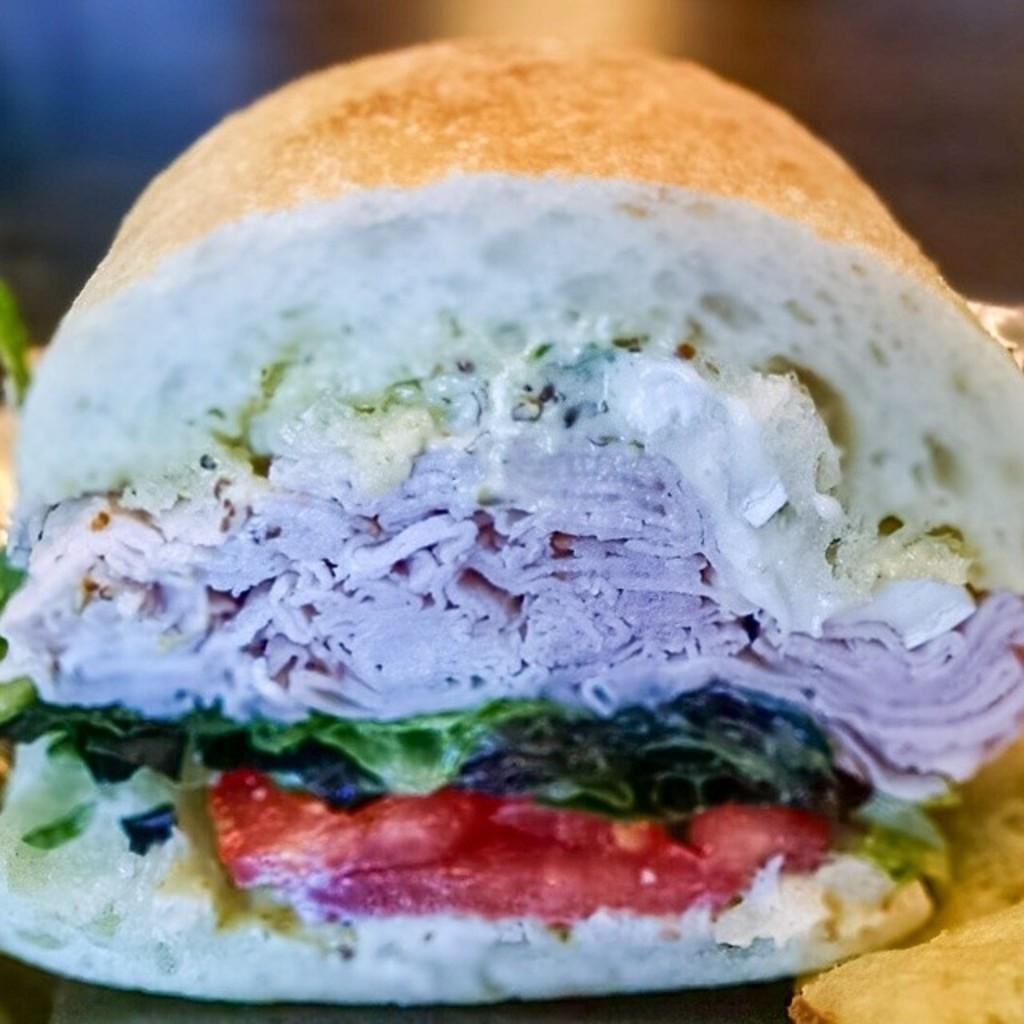What can be seen in the image? There is food in the image. What type of train is visible in the image? There is no train present in the image; it only features food. What color is the bean on the plate in the image? There is no bean present in the image; it only features food. 